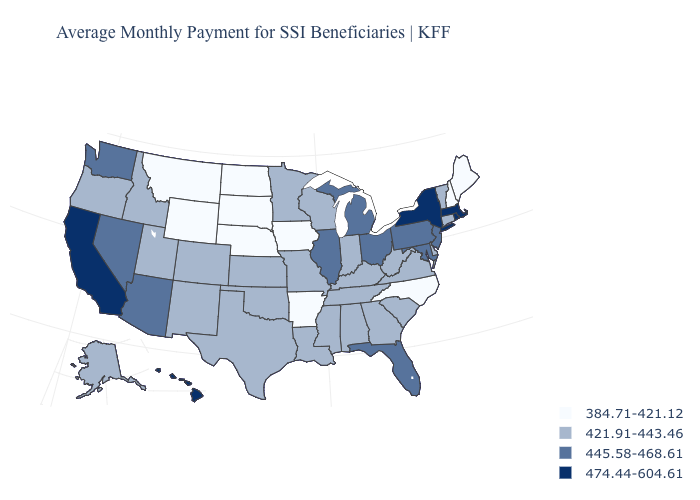Name the states that have a value in the range 384.71-421.12?
Give a very brief answer. Arkansas, Iowa, Maine, Montana, Nebraska, New Hampshire, North Carolina, North Dakota, South Dakota, Wyoming. How many symbols are there in the legend?
Be succinct. 4. Does the map have missing data?
Be succinct. No. Name the states that have a value in the range 421.91-443.46?
Concise answer only. Alabama, Alaska, Colorado, Connecticut, Delaware, Georgia, Idaho, Indiana, Kansas, Kentucky, Louisiana, Minnesota, Mississippi, Missouri, New Mexico, Oklahoma, Oregon, South Carolina, Tennessee, Texas, Utah, Vermont, Virginia, West Virginia, Wisconsin. Which states have the lowest value in the Northeast?
Quick response, please. Maine, New Hampshire. Does the map have missing data?
Answer briefly. No. What is the highest value in the USA?
Write a very short answer. 474.44-604.61. Among the states that border Utah , does Wyoming have the lowest value?
Short answer required. Yes. Which states have the lowest value in the West?
Be succinct. Montana, Wyoming. Name the states that have a value in the range 445.58-468.61?
Short answer required. Arizona, Florida, Illinois, Maryland, Michigan, Nevada, New Jersey, Ohio, Pennsylvania, Washington. What is the value of Illinois?
Answer briefly. 445.58-468.61. Among the states that border New York , which have the lowest value?
Keep it brief. Connecticut, Vermont. Among the states that border Utah , does Wyoming have the highest value?
Write a very short answer. No. Among the states that border Rhode Island , which have the highest value?
Write a very short answer. Massachusetts. What is the value of Illinois?
Write a very short answer. 445.58-468.61. 